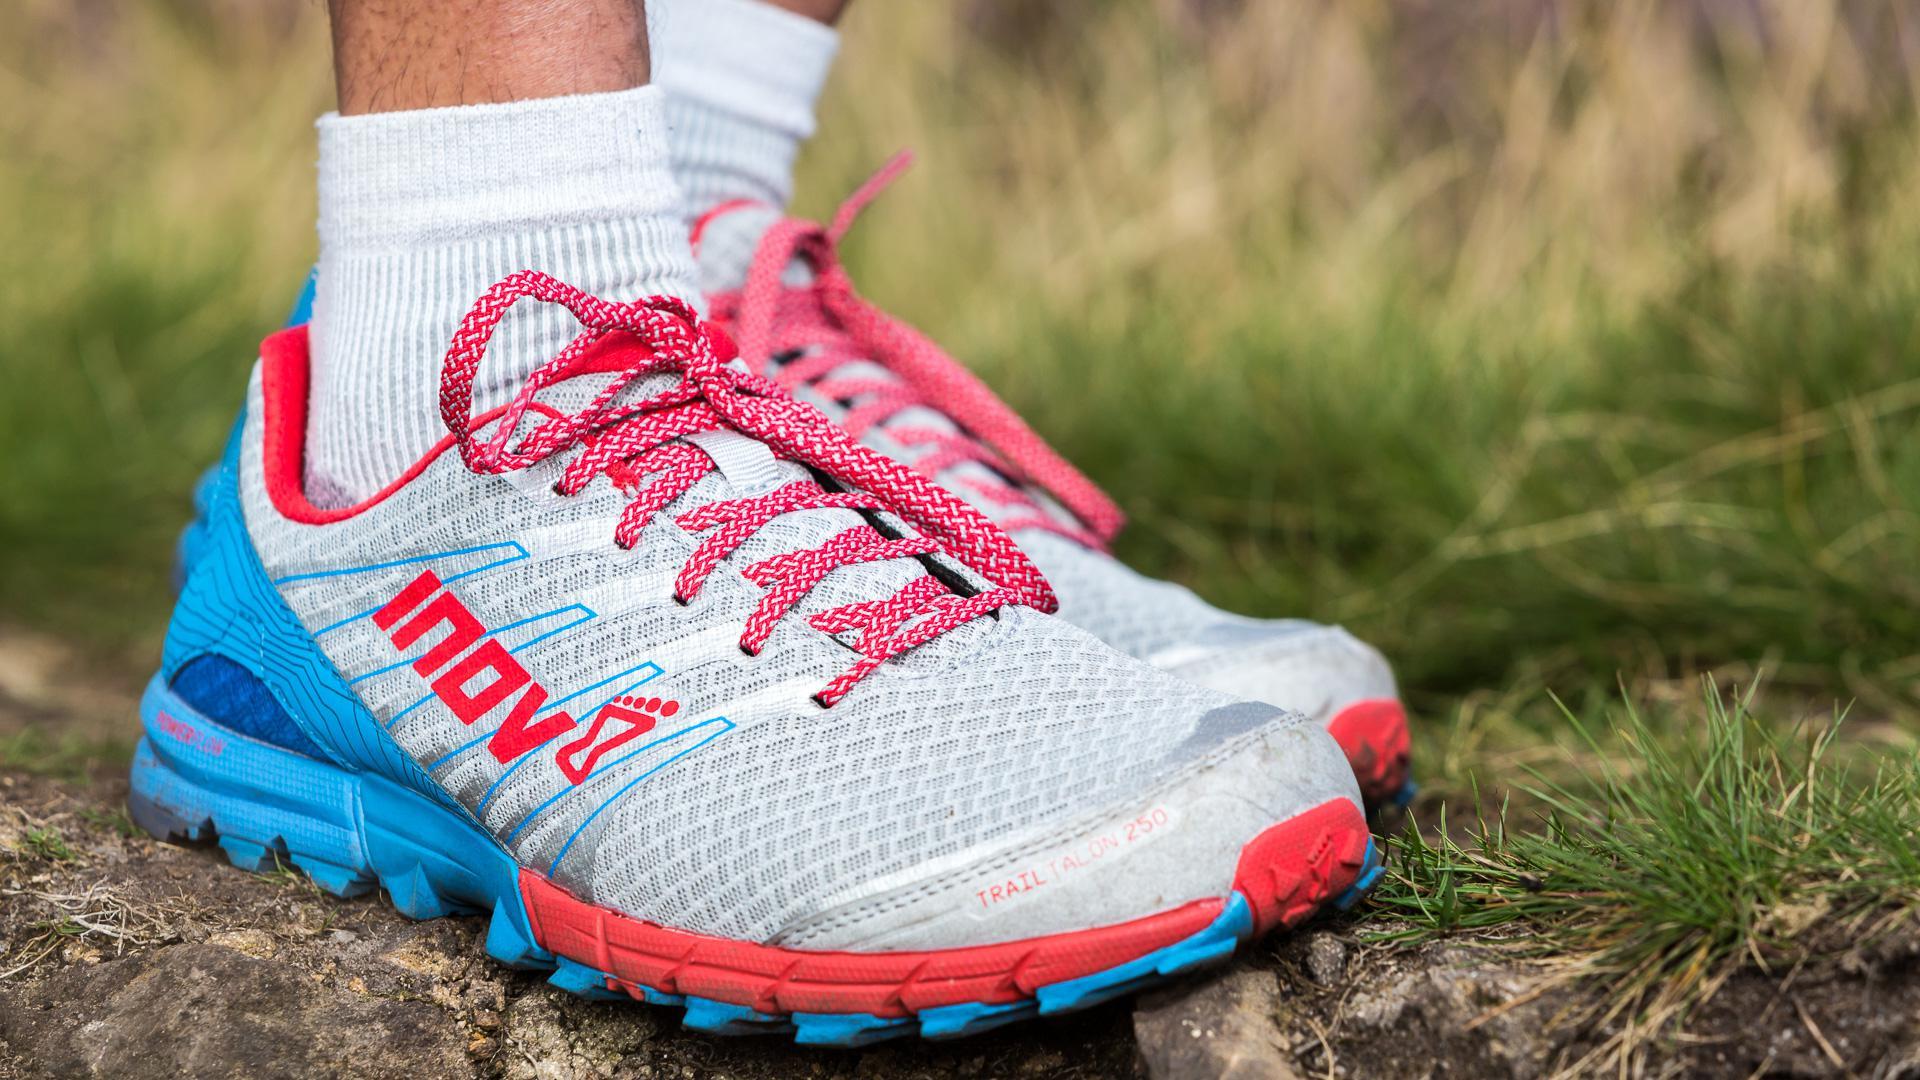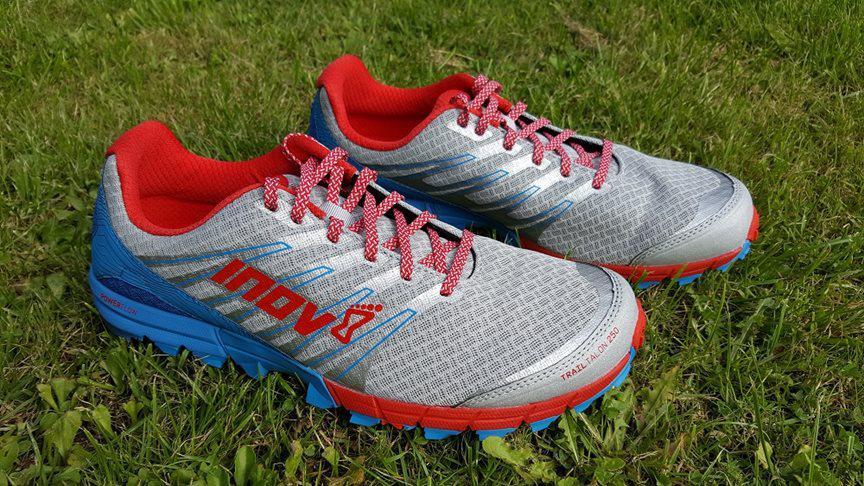The first image is the image on the left, the second image is the image on the right. Given the left and right images, does the statement "One of the shoes in one of the images is turned on its side." hold true? Answer yes or no. No. 